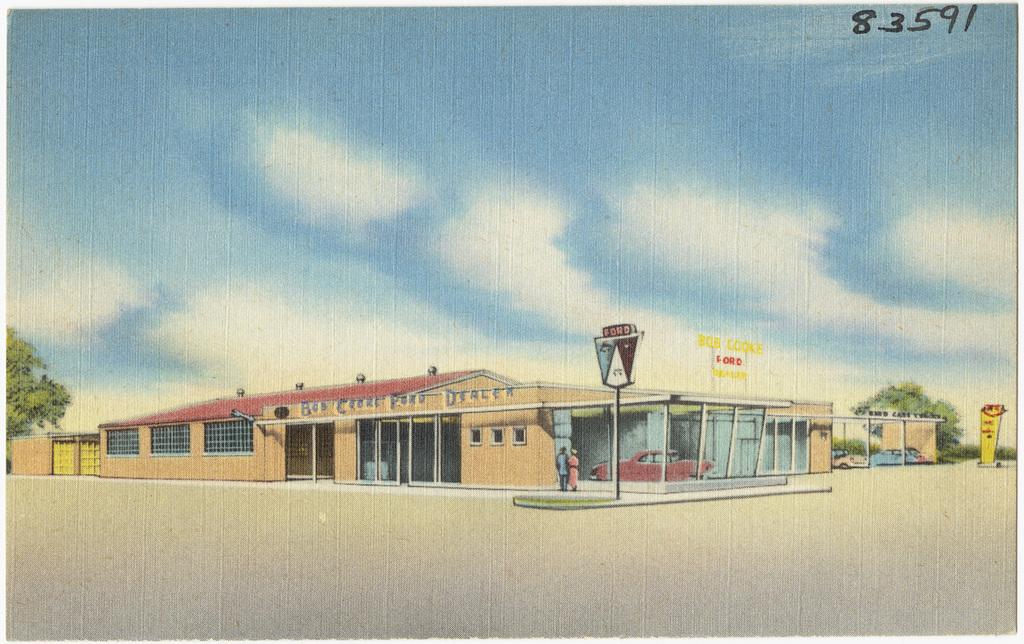What number photo is this?
Ensure brevity in your answer.  83591. What type of dealership is this?
Offer a very short reply. Ford. 